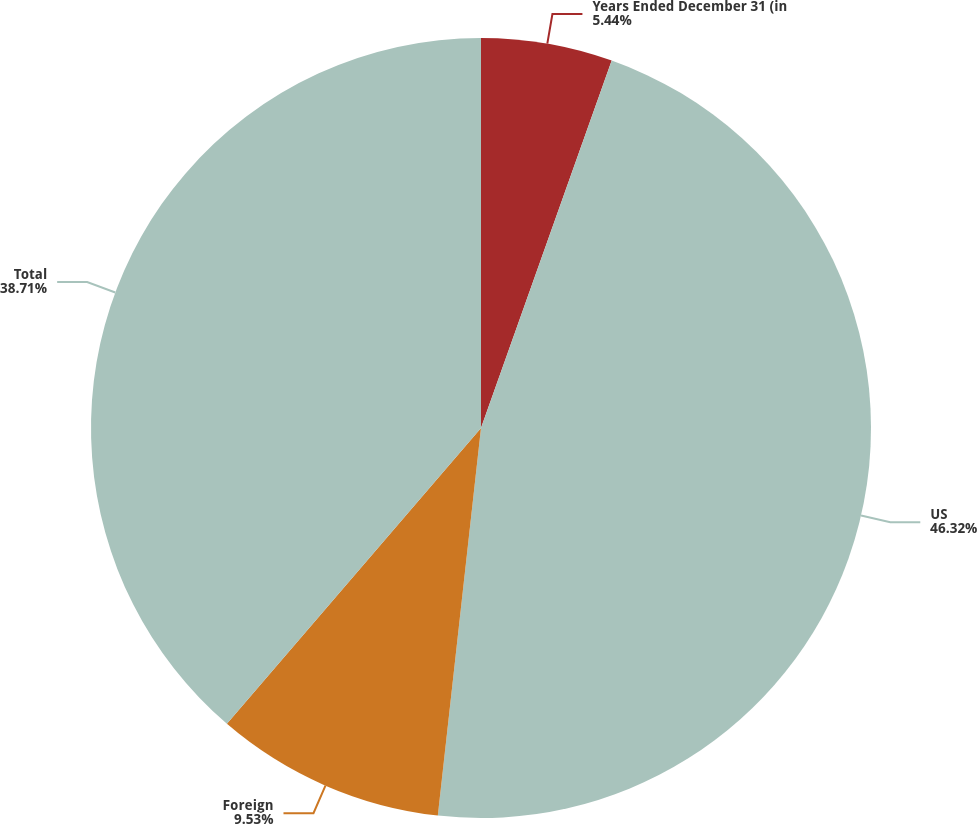<chart> <loc_0><loc_0><loc_500><loc_500><pie_chart><fcel>Years Ended December 31 (in<fcel>US<fcel>Foreign<fcel>Total<nl><fcel>5.44%<fcel>46.33%<fcel>9.53%<fcel>38.71%<nl></chart> 